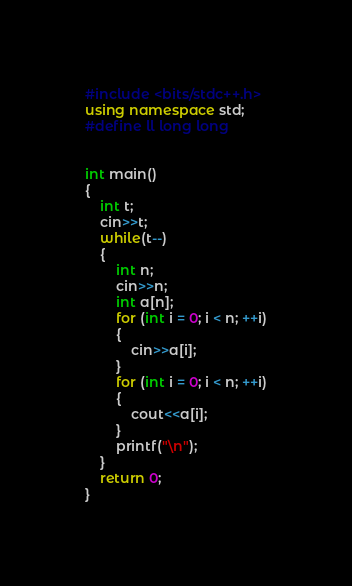Convert code to text. <code><loc_0><loc_0><loc_500><loc_500><_C++_>#include <bits/stdc++.h>
using namespace std;
#define ll long long
 
 
int main()
{
	int t;
	cin>>t;
	while(t--)
	{
		int n;
		cin>>n;
		int a[n];
		for (int i = 0; i < n; ++i)
		{
			cin>>a[i];
		}
		for (int i = 0; i < n; ++i)
		{
			cout<<a[i];
		}
		printf("\n");
	}
	return 0;
}</code> 